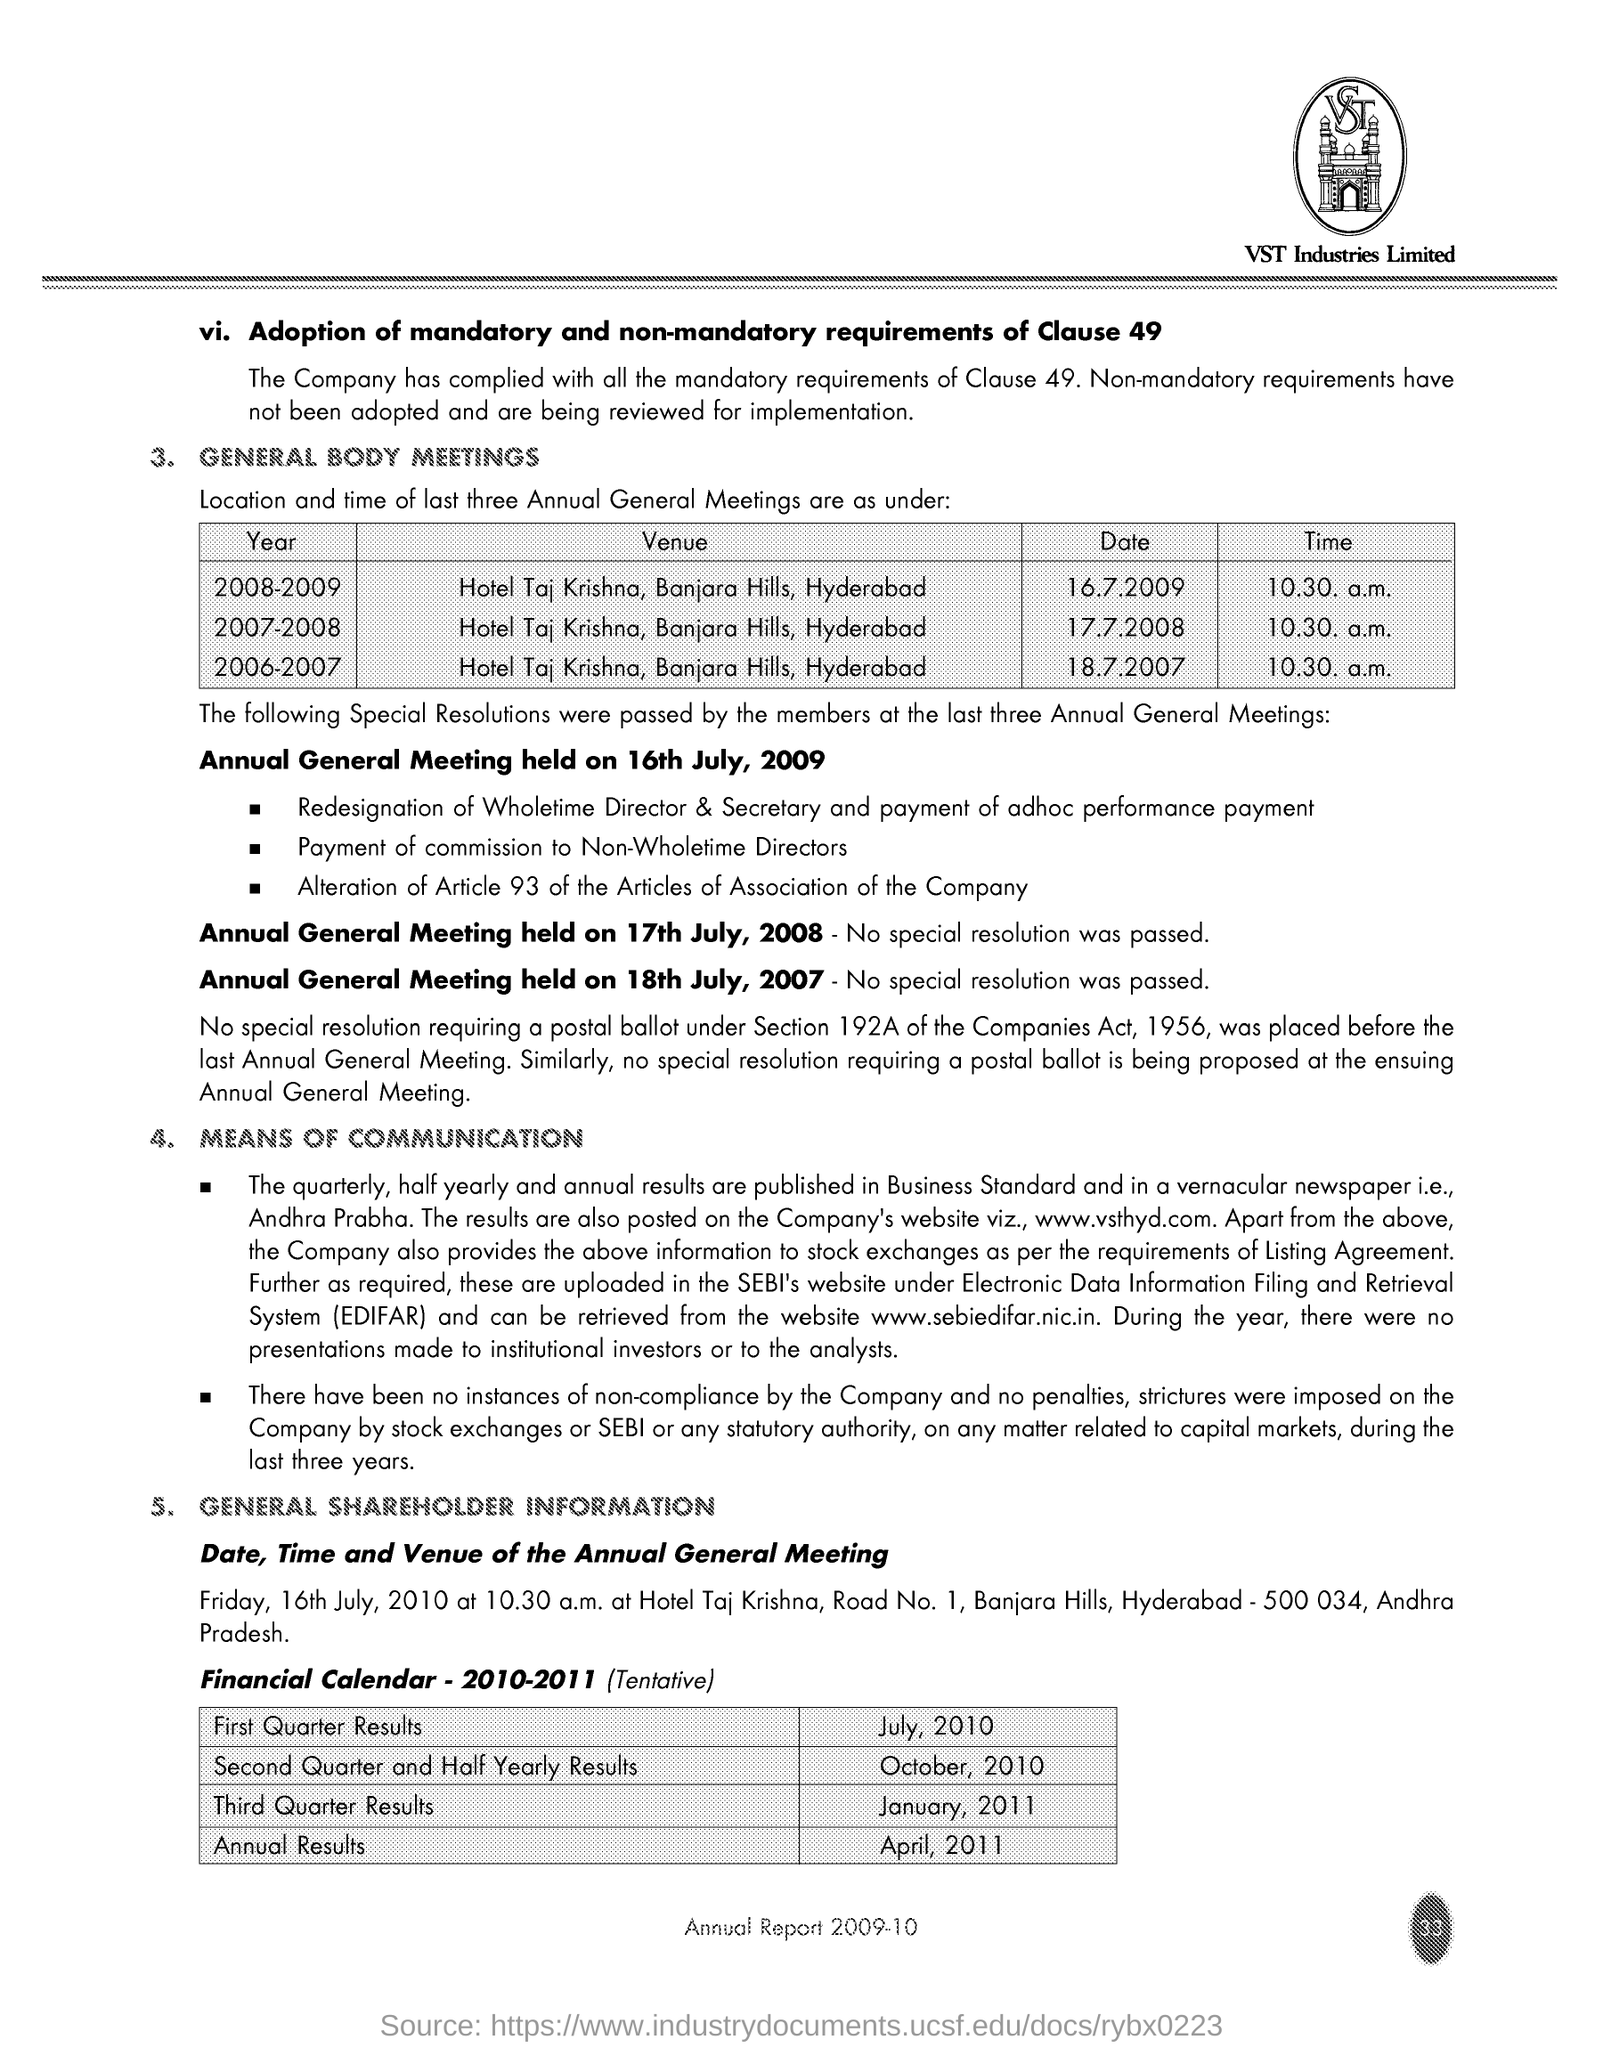Indicate a few pertinent items in this graphic. The name of the company is VST Industries Limited. 